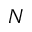Convert formula to latex. <formula><loc_0><loc_0><loc_500><loc_500>N</formula> 